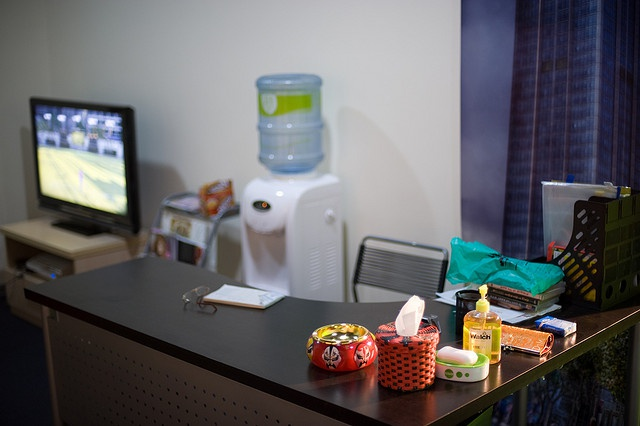Describe the objects in this image and their specific colors. I can see tv in gray, beige, black, and darkgray tones, bottle in gray, darkgray, and olive tones, chair in gray, darkgray, and black tones, and bottle in gray, orange, tan, khaki, and gold tones in this image. 